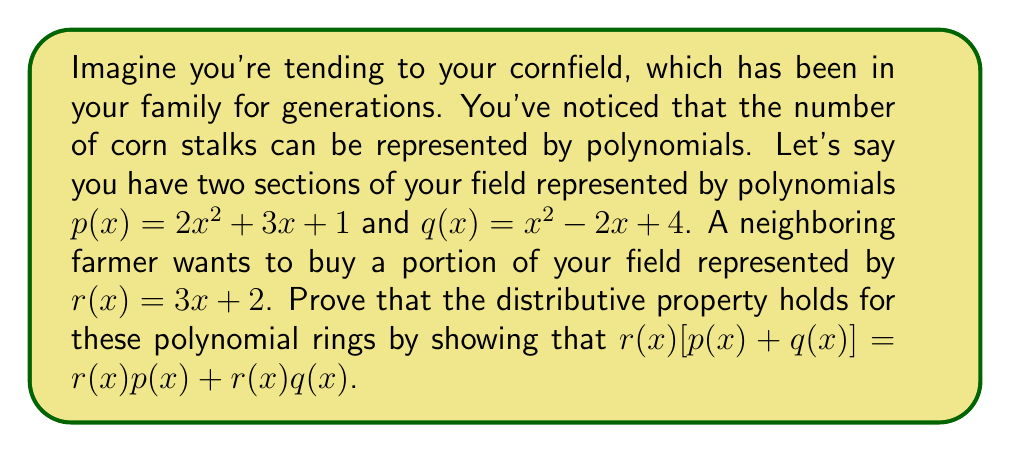Show me your answer to this math problem. Let's approach this step-by-step:

1) First, let's calculate $p(x) + q(x)$:
   $p(x) + q(x) = (2x^2 + 3x + 1) + (x^2 - 2x + 4)$
                $= 3x^2 + x + 5$

2) Now, let's multiply $r(x)$ by $[p(x) + q(x)]$:
   $r(x)[p(x) + q(x)] = (3x + 2)(3x^2 + x + 5)$
                       $= 9x^3 + 3x^2 + 15x + 6x^2 + 2x + 10$
                       $= 9x^3 + 9x^2 + 17x + 10$

3) Next, let's calculate $r(x)p(x)$:
   $r(x)p(x) = (3x + 2)(2x^2 + 3x + 1)$
              $= 6x^3 + 9x^2 + 3x + 4x^2 + 6x + 2$
              $= 6x^3 + 13x^2 + 9x + 2$

4) Similarly, let's calculate $r(x)q(x)$:
   $r(x)q(x) = (3x + 2)(x^2 - 2x + 4)$
              $= 3x^3 - 6x^2 + 12x + 2x^2 - 4x + 8$
              $= 3x^3 - 4x^2 + 8x + 8$

5) Now, let's add $r(x)p(x)$ and $r(x)q(x)$:
   $r(x)p(x) + r(x)q(x) = (6x^3 + 13x^2 + 9x + 2) + (3x^3 - 4x^2 + 8x + 8)$
                         $= 9x^3 + 9x^2 + 17x + 10$

6) We can see that the result from step 2 and step 5 are identical:
   $r(x)[p(x) + q(x)] = r(x)p(x) + r(x)q(x) = 9x^3 + 9x^2 + 17x + 10$

Therefore, we have proven that the distributive property holds for these polynomial rings.
Answer: $r(x)[p(x) + q(x)] = r(x)p(x) + r(x)q(x) = 9x^3 + 9x^2 + 17x + 10$ 